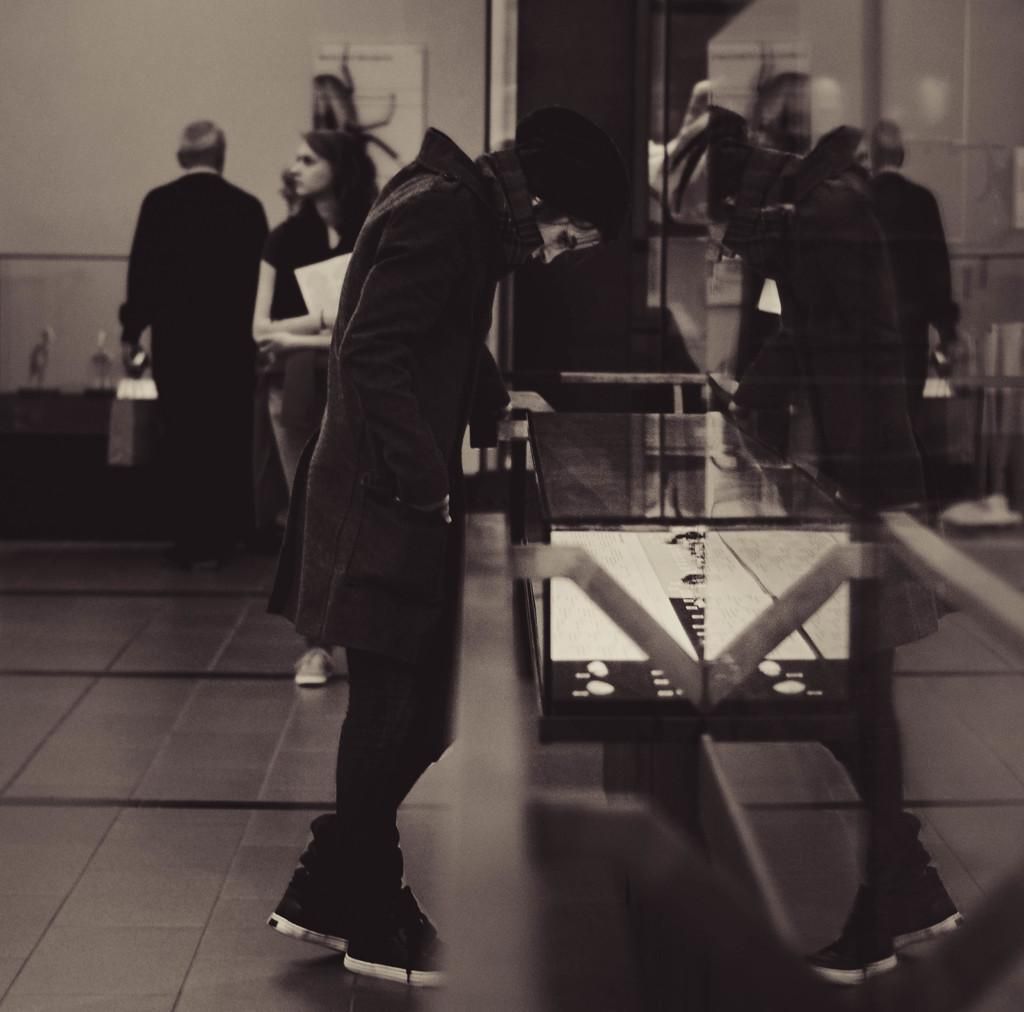What is happening in the image? There is a group of people standing in the image. Can you describe the person in the background? There is a person holding papers in the background of the image. What is the color scheme of the image? The image is in black and white. How many toes can be seen on the people in the image? There is no way to determine the number of toes visible on the people in the image, as the image is in black and white and does not show the feet of the individuals. 